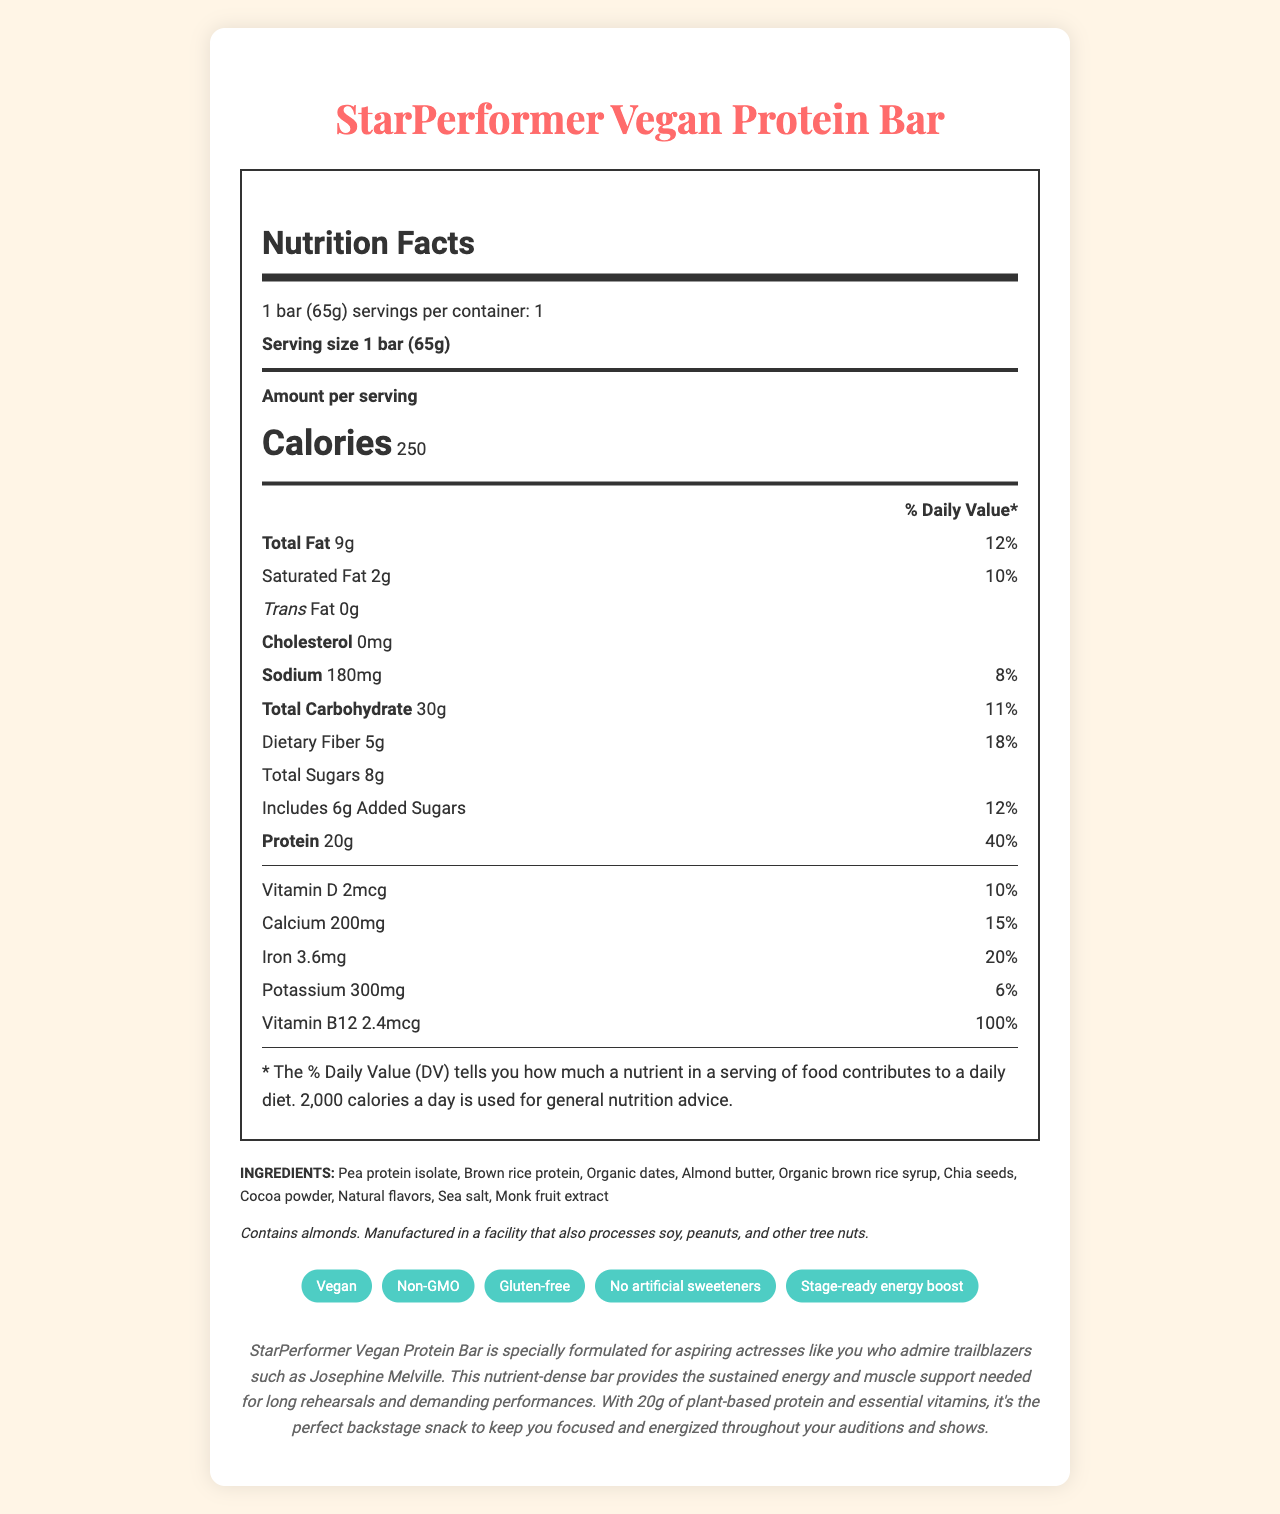what is the product’s name? The product name is mentioned at the top of the document.
Answer: StarPerformer Vegan Protein Bar what is the serving size for this protein bar? The serving size is listed right under the product name and is stated as "1 bar (65g)".
Answer: 1 bar (65g) how many grams of protein are in one bar? The protein content per serving is listed as 20g.
Answer: 20g what percentage of the daily value for dietary fiber does one bar provide? It is mentioned under the dietary fiber content in the nutrition facts section.
Answer: 18% how much cholesterol is in one serving of the bar? The cholesterol content is listed as 0mg.
Answer: 0mg which allergen does this product contain? A. Soy B. Peanuts C. Almonds D. Wheat The document mentions that the bar contains almonds under the allergen information section.
Answer: C what is the total fat content of the bar, and what percentage of the daily value does it represent? The total fat content is listed as 9g and 12% of the daily value.
Answer: 9g, 12% is this product gluten-free? The product is labeled as "Gluten-free" in the marketing claims section.
Answer: Yes what is the main purpose of this protein bar as described in the text? The product description states that it is specially formulated to provide sustained energy and muscle support needed for long rehearsals and demanding performances.
Answer: To provide sustained energy and muscle support for long rehearsals and demanding performances. how many servings are there in one container? It is mentioned at the top of the nutrition facts section as "1 serving per container."
Answer: 1 what is not found in this product based on the label? The marketing claims section lists "No artificial sweeteners" as one of the claims.
Answer: Artificial sweeteners how much-added sugars does one bar contain? The added sugars content is listed as 6g.
Answer: 6g what is the total carbohydrate content per serving? The total carbohydrate content is listed as 30g.
Answer: 30g which of the following is NOT an ingredient in this product? A. Brown rice protein B. Almond butter C. Organic honey D. Pea protein isolate The list of ingredients does not include organic honey.
Answer: C what is the calorie content of one bar? The calorie content per serving is listed as 250 calories.
Answer: 250 calories name one vitamin and its daily value percentage provided by the bar. Vitamin B12 is listed with 2.4mcg, which is 100% of the daily value.
Answer: Vitamin B12, 100% how is the document designed based on its appearance? The document is visually appealing, using a clear and organized layout to display comprehensive nutritional information, product ingredients, and benefits.
Answer: The document is an aesthetically designed nutrition facts label for a vegan protein bar, with details about serving size, nutritional content, ingredients, allergen information, marketing claims, and a product description. what country is the product manufactured in? There is no information in the document indicating the country of manufacture.
Answer: Cannot be determined 